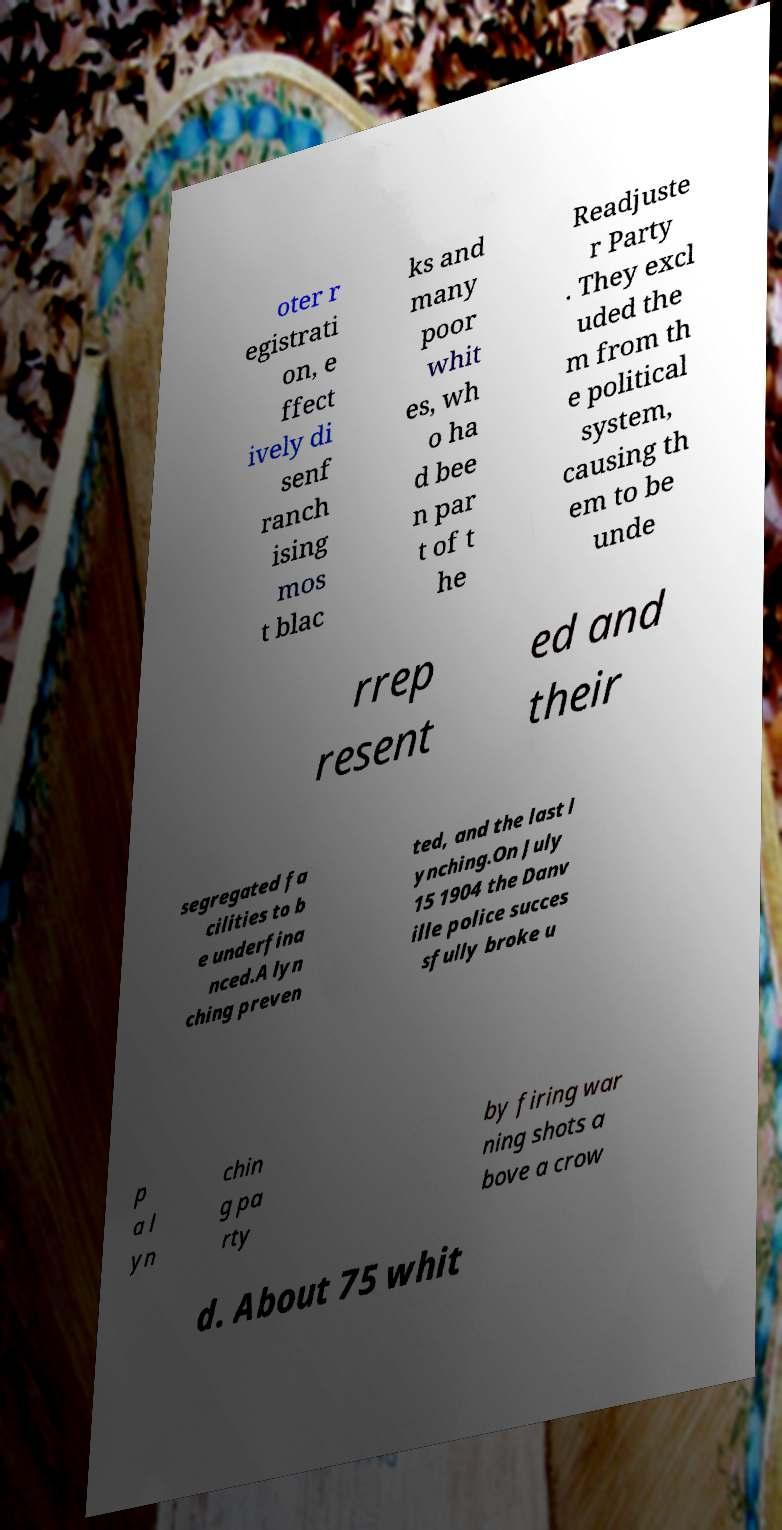For documentation purposes, I need the text within this image transcribed. Could you provide that? oter r egistrati on, e ffect ively di senf ranch ising mos t blac ks and many poor whit es, wh o ha d bee n par t of t he Readjuste r Party . They excl uded the m from th e political system, causing th em to be unde rrep resent ed and their segregated fa cilities to b e underfina nced.A lyn ching preven ted, and the last l ynching.On July 15 1904 the Danv ille police succes sfully broke u p a l yn chin g pa rty by firing war ning shots a bove a crow d. About 75 whit 